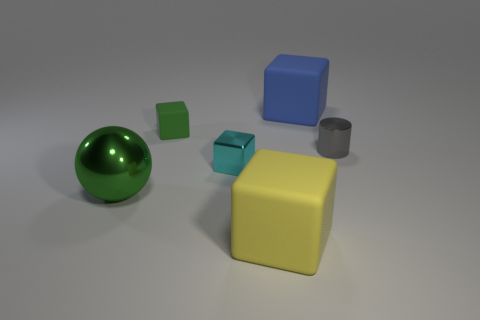Add 1 big cyan rubber balls. How many objects exist? 7 Subtract all spheres. How many objects are left? 5 Add 6 large green balls. How many large green balls exist? 7 Subtract 0 cyan cylinders. How many objects are left? 6 Subtract all yellow rubber spheres. Subtract all large blue things. How many objects are left? 5 Add 6 small shiny cylinders. How many small shiny cylinders are left? 7 